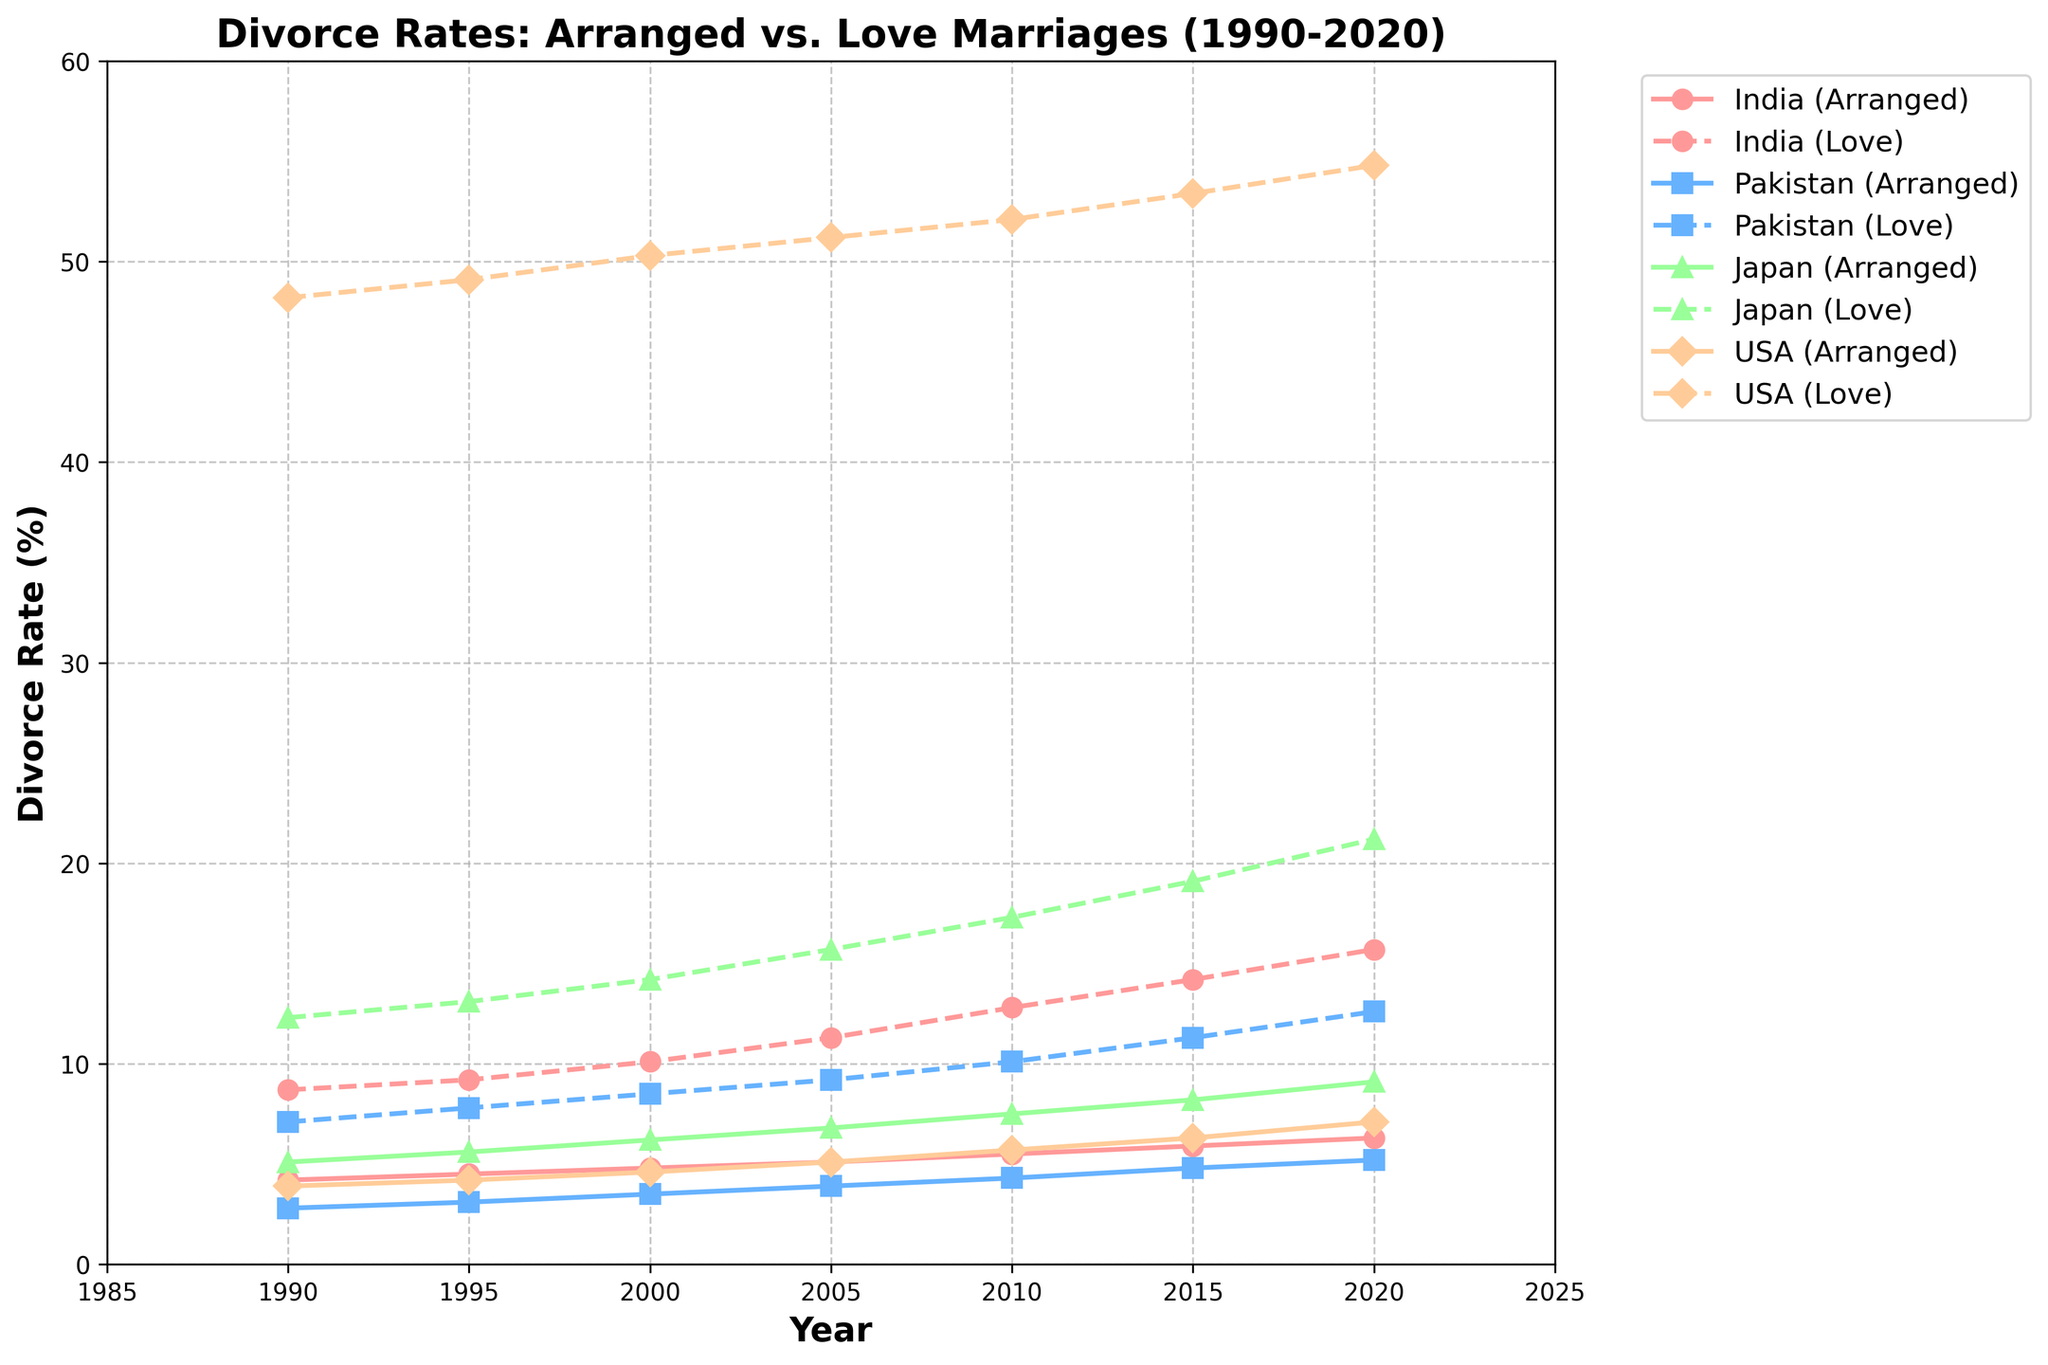What is the general trend of divorce rates in arranged marriages vs love marriages in India from 1990 to 2020? From the line chart, observe that both the divorce rates in arranged and love marriages in India increase over time. Arranged marriages start from 4.2% in 1990 and rise to 6.3% in 2020. Love marriages start from 8.7% in 1990 and rise to 15.7% in 2020.
Answer: Increasing trend How do the divorce rates of arranged marriages in the USA in 2020 compare with those in Pakistan in the same year? From the figure, check the divorce rate in the USA for arranged marriages in 2020, which is 7.1%, and compare it with Pakistan's arranged marriage divorce rate in 2020, which is 5.2%.
Answer: Higher in the USA Which country has the highest divorce rate in love marriages in 2000? Look at the data points for love marriages for each country in 2000. India has 10.1%, Pakistan has 8.5%, Japan has 14.2%, and the USA has 50.3%. The highest value is for the USA.
Answer: USA By how much did the divorce rates for arranged marriages in Japan increase from 1990 to 2020? Subtract the divorce rate for arranged marriages in Japan in 1990 (5.1%) from the rate in 2020 (9.1%).
Answer: 4.0% Which type of marriage generally has consistently higher divorce rates across all countries and years shown in the chart? By visually inspecting the chart, observe that love marriages consistently have higher divorce rates compared to arranged marriages in all countries and throughout all the years presented.
Answer: Love marriages What is the average increase in divorce rates in arranged marriages in India every 5 years? To find the average increase in India’s arranged marriage rates, sum the increases from each interval: (4.5-4.2), (4.8-4.5), (5.1-4.8), (5.5-5.1), (5.9-5.5), (6.3-5.9). The individual increases are 0.3, 0.3, 0.3, 0.4, 0.4, and 0.4 respectively. Sum these increases (0.3+0.3+0.3+0.4+0.4+0.4 = 2.1) and divide by 6 (the number of intervals).
Answer: 0.35% Did the divorce rates for arranged marriages ever surpass those for love marriages in any country from 1990 to 2020? Visual inspection shows that at no point do the lines representing arranged marriages surpass the lines for love marriages for any of the countries.
Answer: No By how much did the divorce rates in love marriages rise from 1995 to 2020 in Pakistan? Subtract the divorce rate in 1995 (7.8%) from the rate in 2020 (12.6%).
Answer: 4.8% What is the difference between the divorce rates of arranged and love marriages in Japan in 2010? Observe Japan's divorce rate for arranged marriages in 2010 is 7.5%, and love marriages is 17.3%. Subtract 7.5% from 17.3%.
Answer: 9.8% 